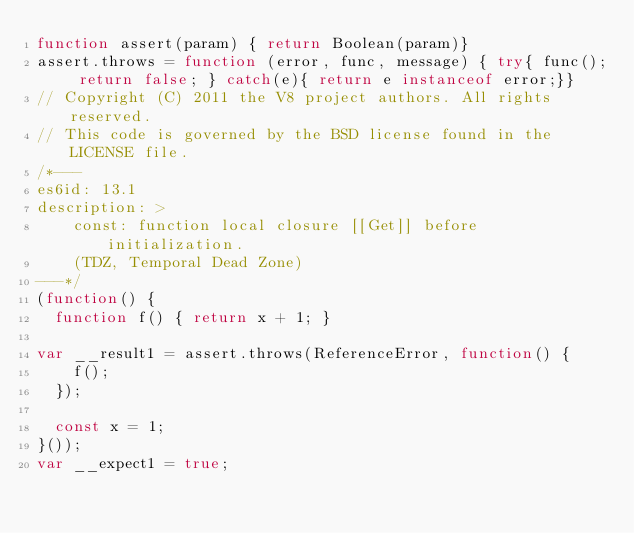<code> <loc_0><loc_0><loc_500><loc_500><_JavaScript_>function assert(param) { return Boolean(param)}
assert.throws = function (error, func, message) { try{ func(); return false; } catch(e){ return e instanceof error;}}
// Copyright (C) 2011 the V8 project authors. All rights reserved.
// This code is governed by the BSD license found in the LICENSE file.
/*---
es6id: 13.1
description: >
    const: function local closure [[Get]] before initialization.
    (TDZ, Temporal Dead Zone)
---*/
(function() {
  function f() { return x + 1; }

var __result1 = assert.throws(ReferenceError, function() {
    f();
  });

  const x = 1;
}());
var __expect1 = true;
</code> 